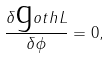Convert formula to latex. <formula><loc_0><loc_0><loc_500><loc_500>\frac { \delta \text  goth{L} } { \delta \phi } = 0 ,</formula> 